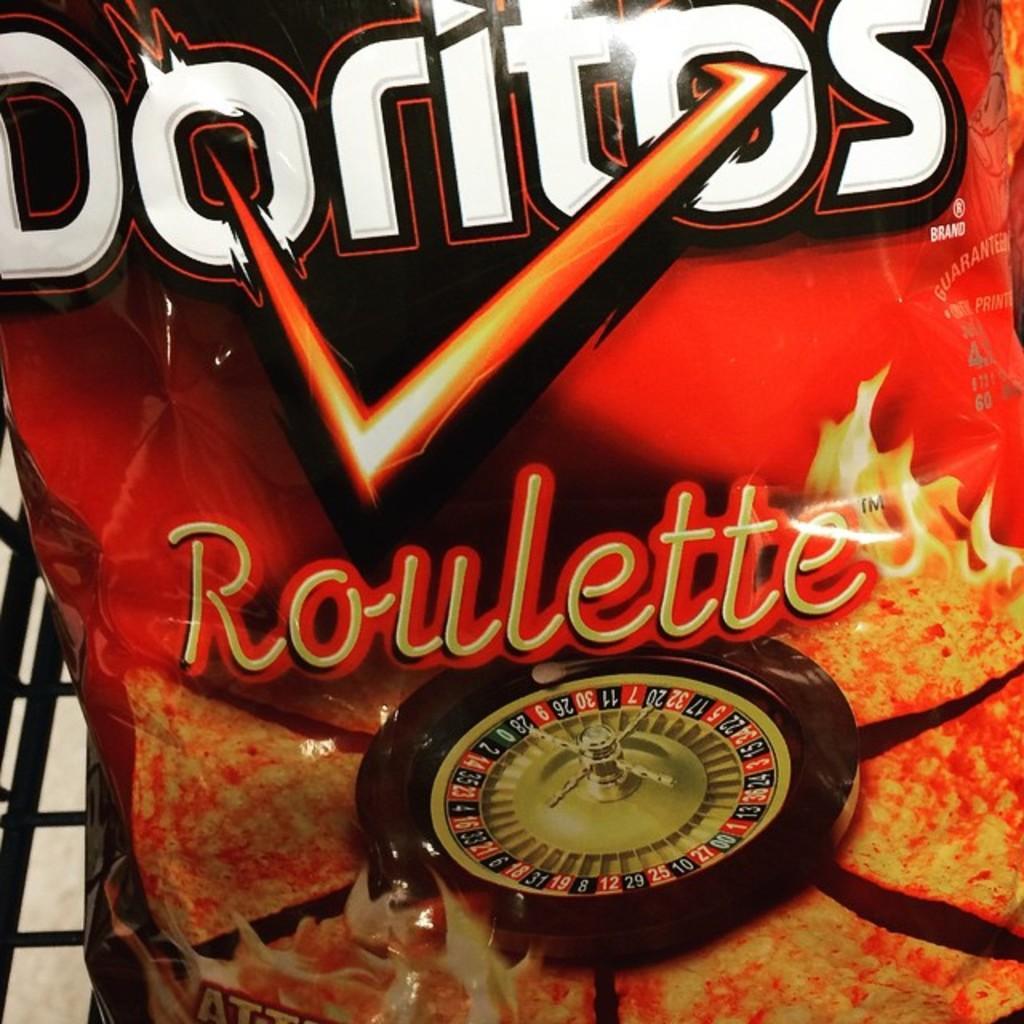Describe this image in one or two sentences. In this image we can see the wrapper of a packed food. 